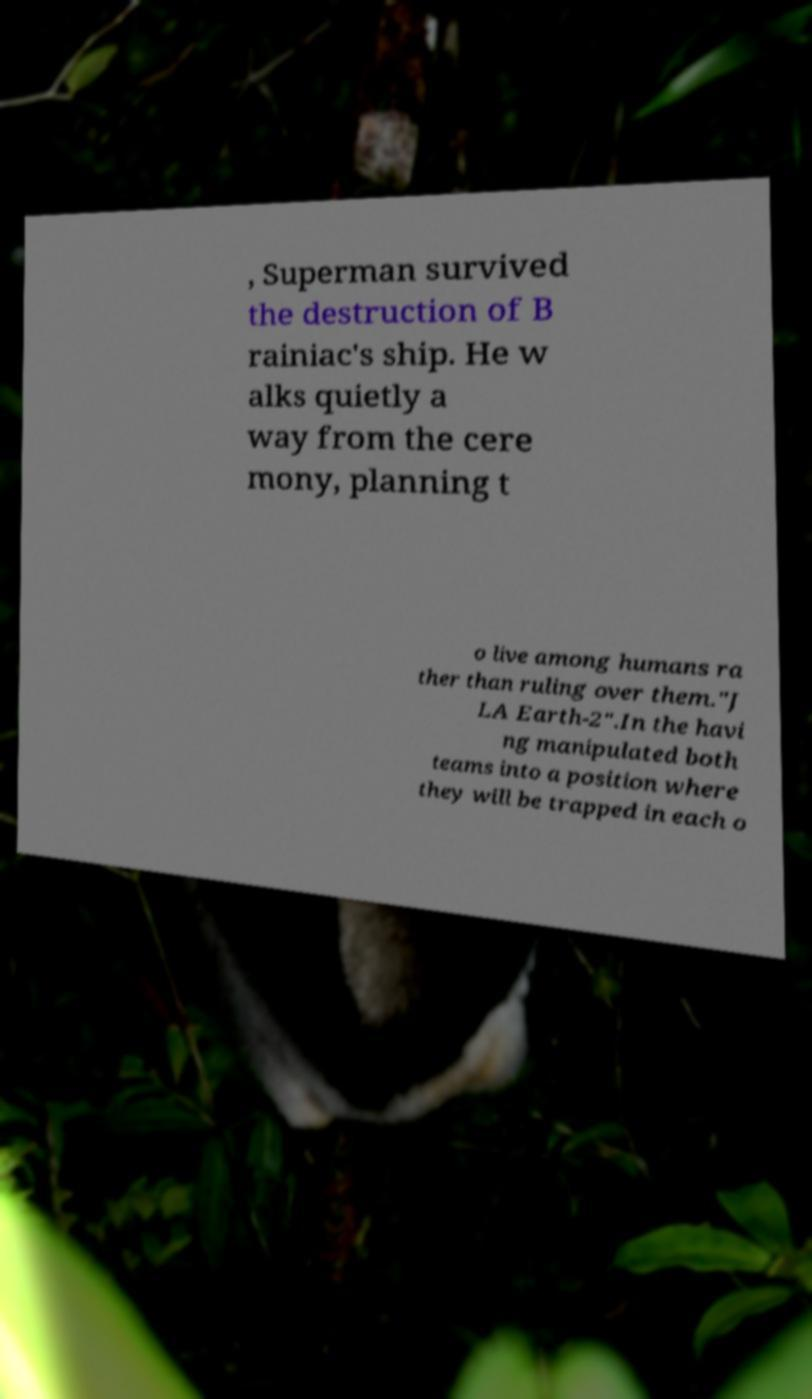I need the written content from this picture converted into text. Can you do that? , Superman survived the destruction of B rainiac's ship. He w alks quietly a way from the cere mony, planning t o live among humans ra ther than ruling over them."J LA Earth-2".In the havi ng manipulated both teams into a position where they will be trapped in each o 